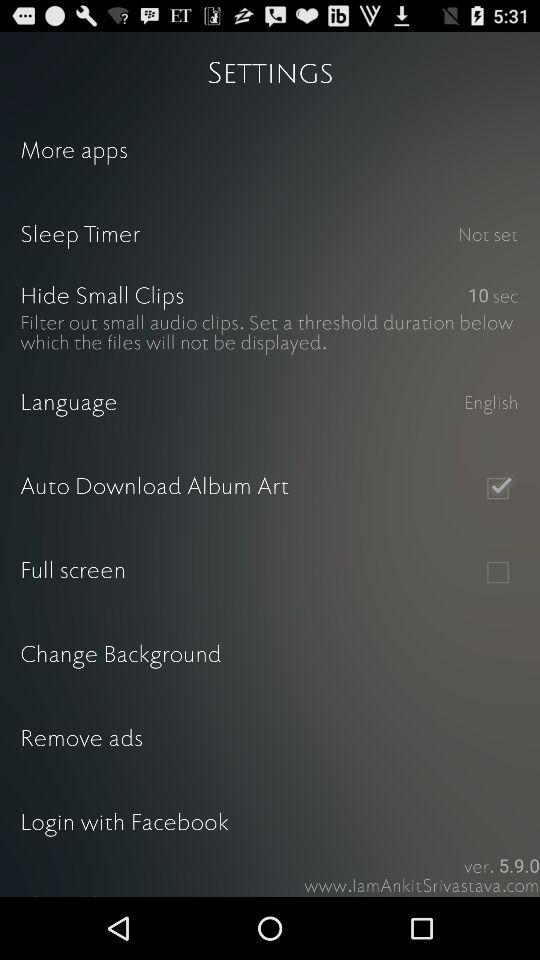What duration is set to hide small clips? The set duration is 10 seconds. 